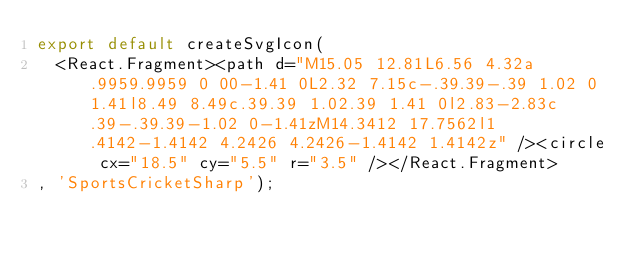<code> <loc_0><loc_0><loc_500><loc_500><_JavaScript_>export default createSvgIcon(
  <React.Fragment><path d="M15.05 12.81L6.56 4.32a.9959.9959 0 00-1.41 0L2.32 7.15c-.39.39-.39 1.02 0 1.41l8.49 8.49c.39.39 1.02.39 1.41 0l2.83-2.83c.39-.39.39-1.02 0-1.41zM14.3412 17.7562l1.4142-1.4142 4.2426 4.2426-1.4142 1.4142z" /><circle cx="18.5" cy="5.5" r="3.5" /></React.Fragment>
, 'SportsCricketSharp');
</code> 